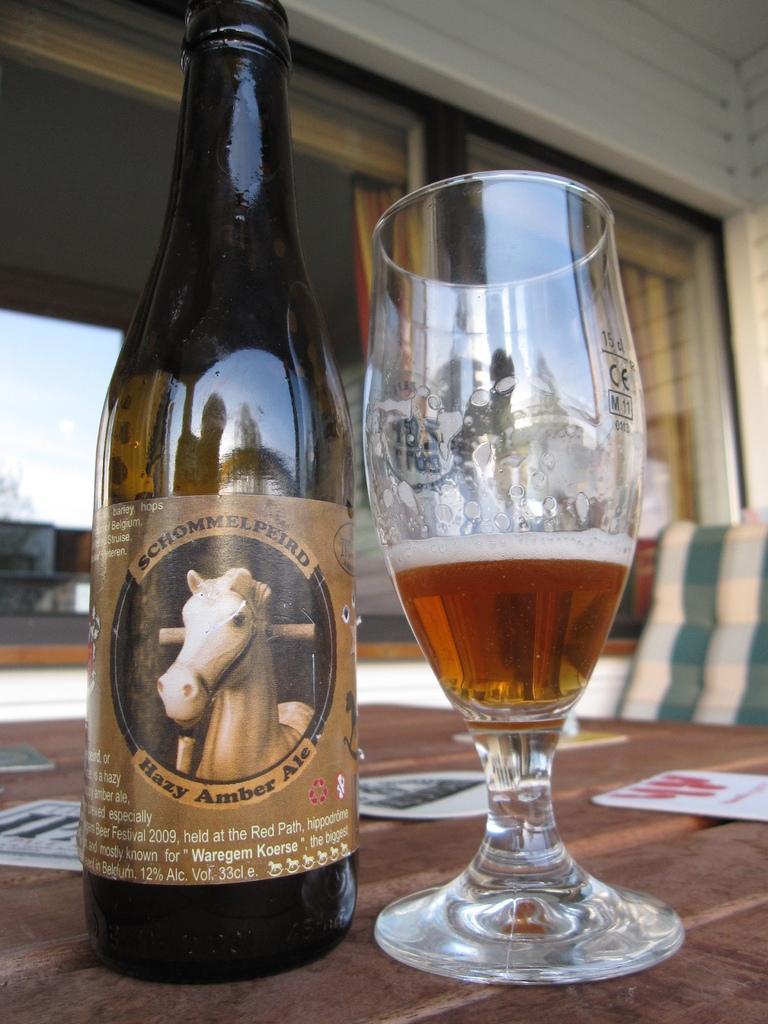Can you describe this image briefly? In the picture we can see a table on it we can see a wine bottle and beside it we can see a glass with some wine in it and behind the table we can see a chair and beside it we can see a wall with a glass window. 